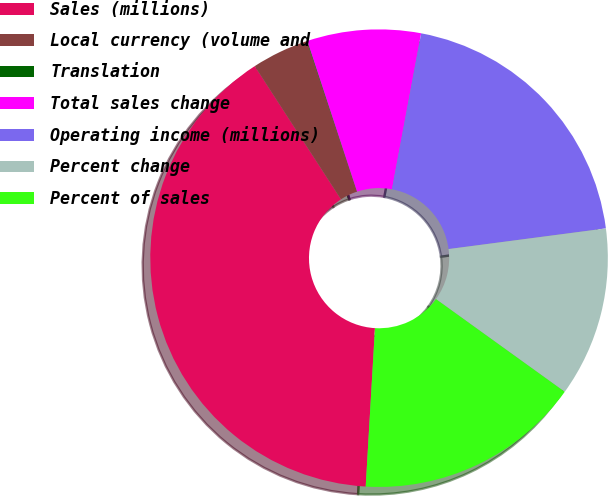Convert chart. <chart><loc_0><loc_0><loc_500><loc_500><pie_chart><fcel>Sales (millions)<fcel>Local currency (volume and<fcel>Translation<fcel>Total sales change<fcel>Operating income (millions)<fcel>Percent change<fcel>Percent of sales<nl><fcel>39.93%<fcel>4.03%<fcel>0.04%<fcel>8.02%<fcel>19.98%<fcel>12.01%<fcel>16.0%<nl></chart> 